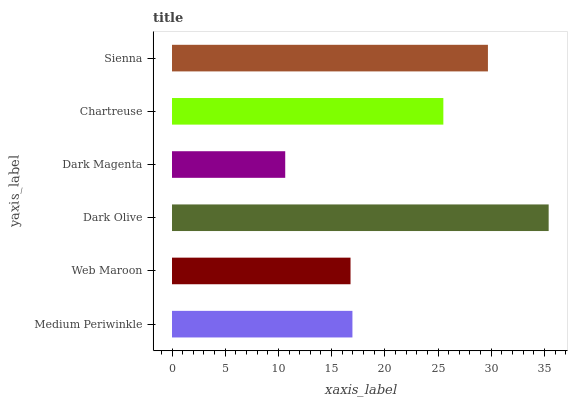Is Dark Magenta the minimum?
Answer yes or no. Yes. Is Dark Olive the maximum?
Answer yes or no. Yes. Is Web Maroon the minimum?
Answer yes or no. No. Is Web Maroon the maximum?
Answer yes or no. No. Is Medium Periwinkle greater than Web Maroon?
Answer yes or no. Yes. Is Web Maroon less than Medium Periwinkle?
Answer yes or no. Yes. Is Web Maroon greater than Medium Periwinkle?
Answer yes or no. No. Is Medium Periwinkle less than Web Maroon?
Answer yes or no. No. Is Chartreuse the high median?
Answer yes or no. Yes. Is Medium Periwinkle the low median?
Answer yes or no. Yes. Is Web Maroon the high median?
Answer yes or no. No. Is Sienna the low median?
Answer yes or no. No. 